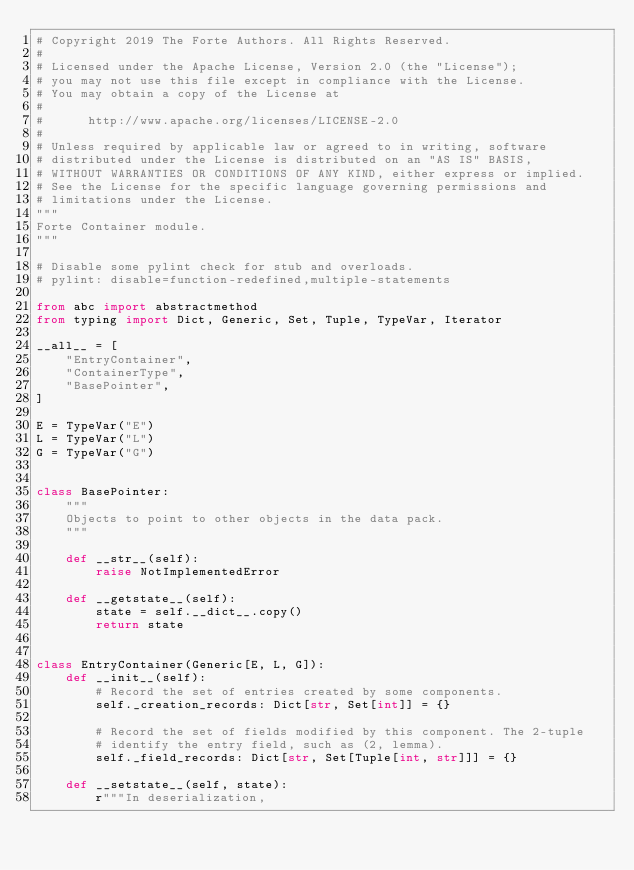<code> <loc_0><loc_0><loc_500><loc_500><_Python_># Copyright 2019 The Forte Authors. All Rights Reserved.
#
# Licensed under the Apache License, Version 2.0 (the "License");
# you may not use this file except in compliance with the License.
# You may obtain a copy of the License at
#
#      http://www.apache.org/licenses/LICENSE-2.0
#
# Unless required by applicable law or agreed to in writing, software
# distributed under the License is distributed on an "AS IS" BASIS,
# WITHOUT WARRANTIES OR CONDITIONS OF ANY KIND, either express or implied.
# See the License for the specific language governing permissions and
# limitations under the License.
"""
Forte Container module.
"""

# Disable some pylint check for stub and overloads.
# pylint: disable=function-redefined,multiple-statements

from abc import abstractmethod
from typing import Dict, Generic, Set, Tuple, TypeVar, Iterator

__all__ = [
    "EntryContainer",
    "ContainerType",
    "BasePointer",
]

E = TypeVar("E")
L = TypeVar("L")
G = TypeVar("G")


class BasePointer:
    """
    Objects to point to other objects in the data pack.
    """

    def __str__(self):
        raise NotImplementedError

    def __getstate__(self):
        state = self.__dict__.copy()
        return state


class EntryContainer(Generic[E, L, G]):
    def __init__(self):
        # Record the set of entries created by some components.
        self._creation_records: Dict[str, Set[int]] = {}

        # Record the set of fields modified by this component. The 2-tuple
        # identify the entry field, such as (2, lemma).
        self._field_records: Dict[str, Set[Tuple[int, str]]] = {}

    def __setstate__(self, state):
        r"""In deserialization,</code> 